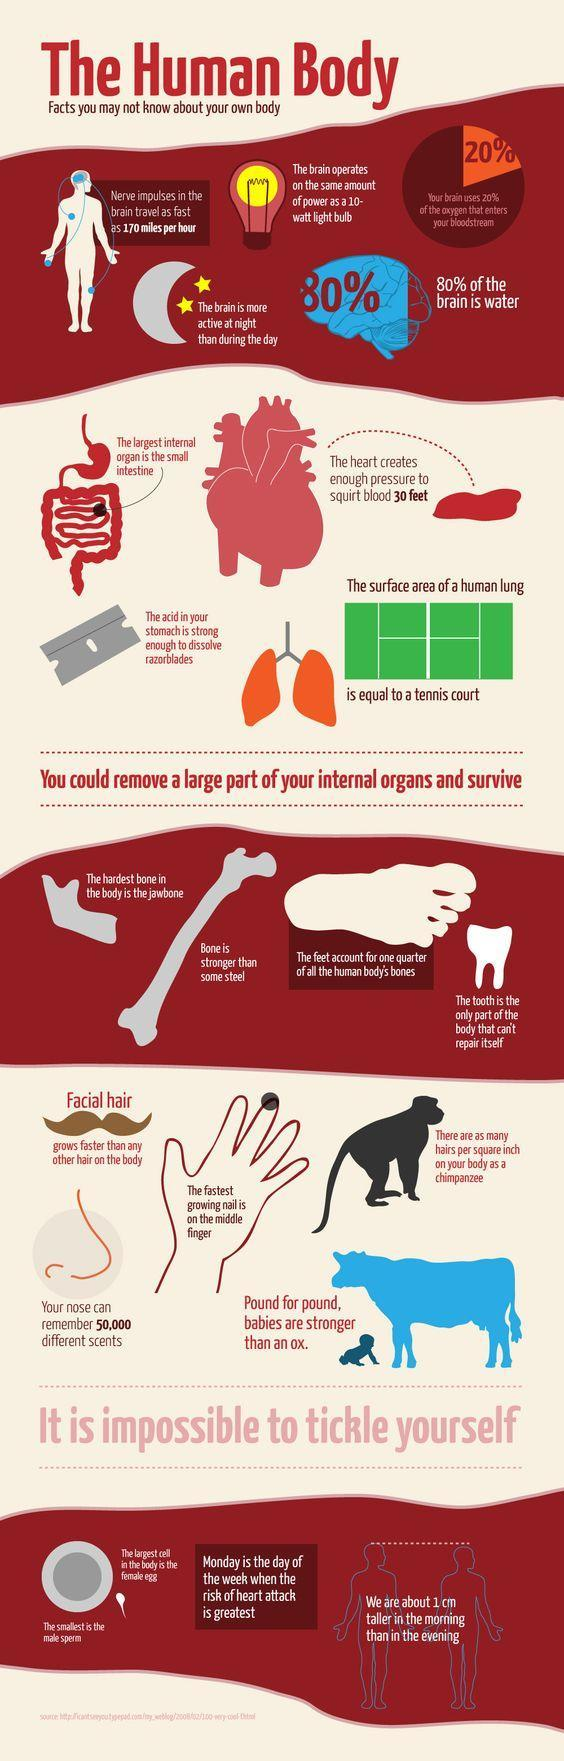Which part of the body cannot repair itself
Answer the question with a short phrase. tooth which is the smallest cell in our body male sperm what can the razor blade be dissolved with the acid in your stomach Where is 25% of the human body's bones found feet What is written inside the diagram of the brain 80% Which time of the day is our height more morning What is written inside the pie chart 20% What is the power of the brain equal to 10-watt 